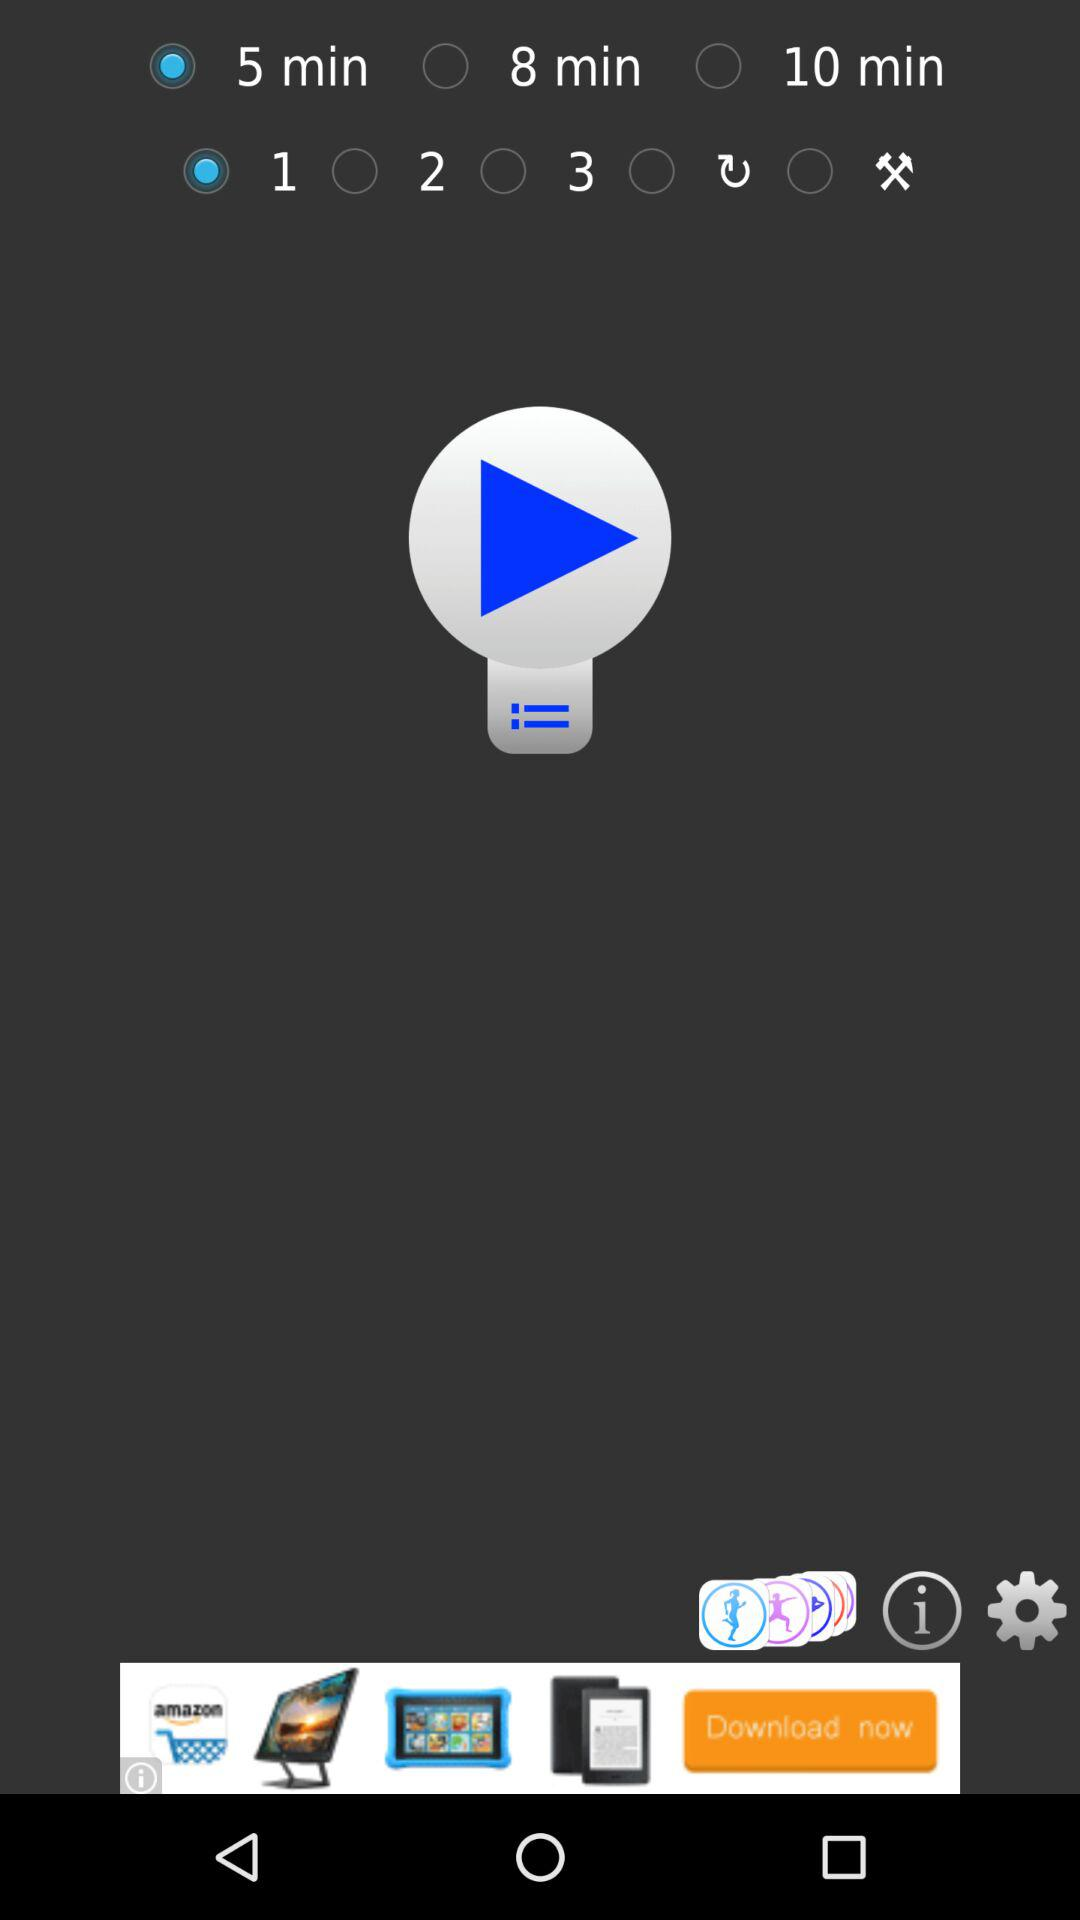How much time is selected? The selected time is 5 minutes. 